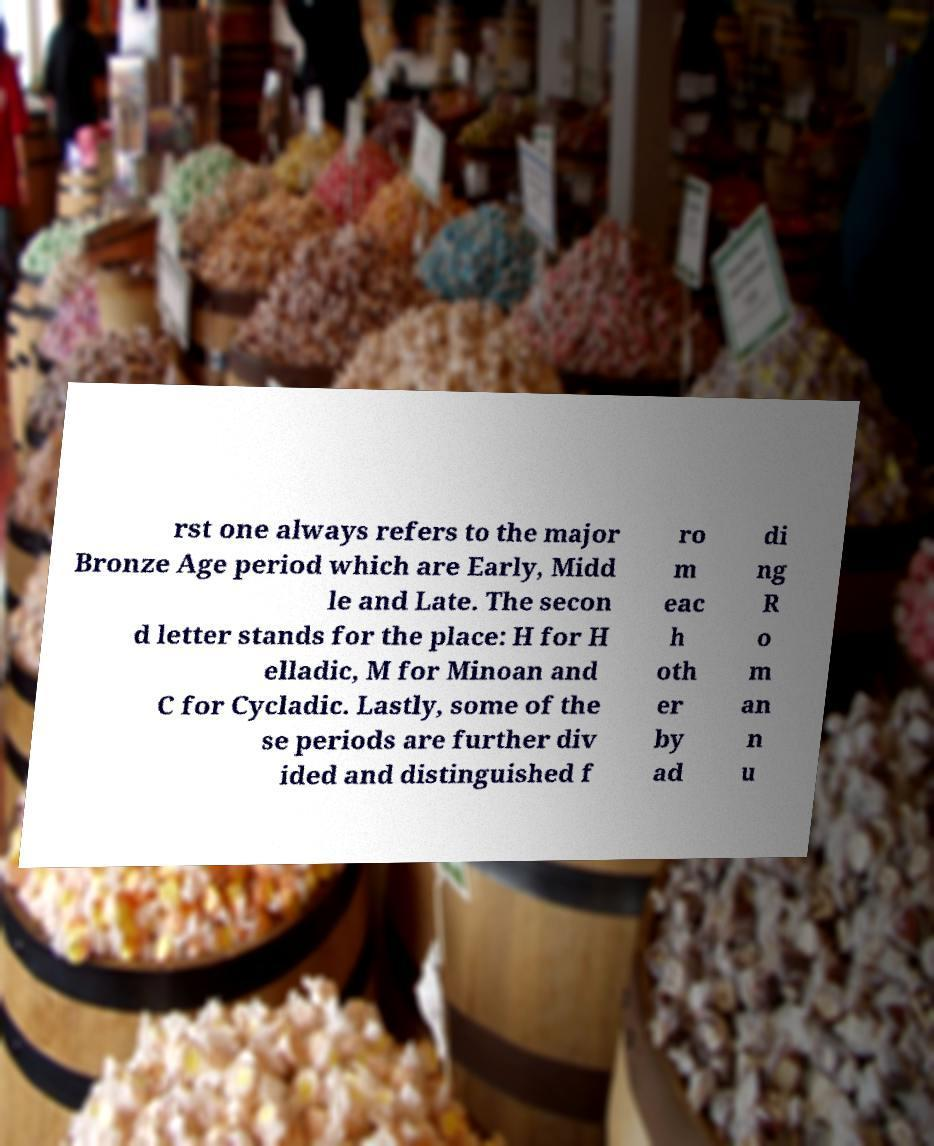Please identify and transcribe the text found in this image. rst one always refers to the major Bronze Age period which are Early, Midd le and Late. The secon d letter stands for the place: H for H elladic, M for Minoan and C for Cycladic. Lastly, some of the se periods are further div ided and distinguished f ro m eac h oth er by ad di ng R o m an n u 